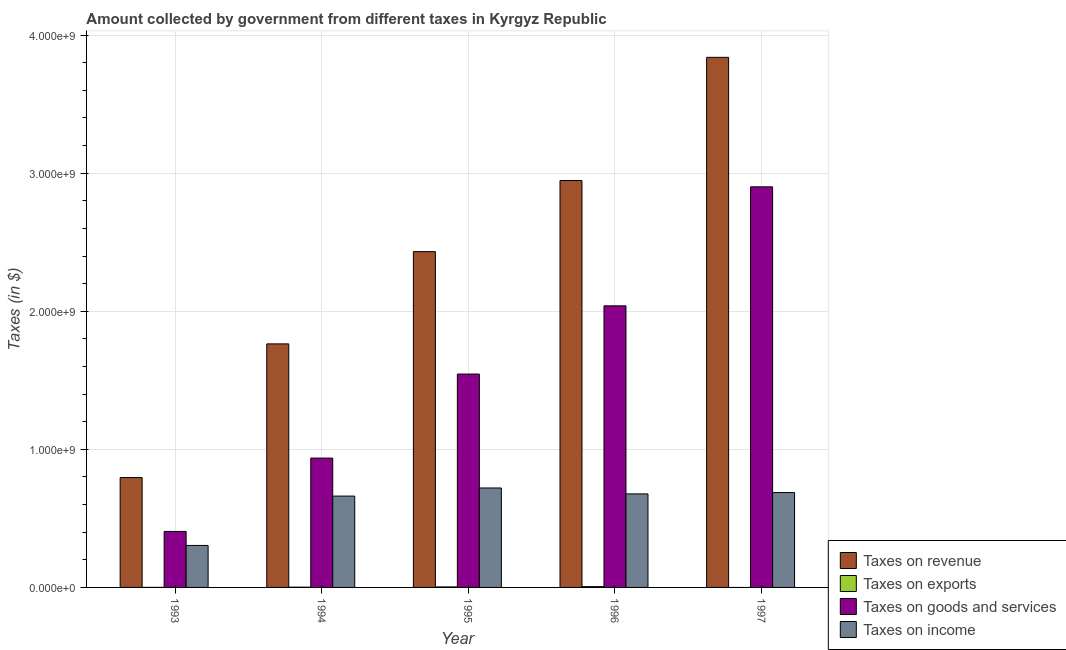Are the number of bars per tick equal to the number of legend labels?
Offer a terse response. No. How many bars are there on the 3rd tick from the right?
Offer a very short reply. 4. In how many cases, is the number of bars for a given year not equal to the number of legend labels?
Give a very brief answer. 1. What is the amount collected as tax on exports in 1995?
Provide a short and direct response. 3.56e+06. Across all years, what is the maximum amount collected as tax on goods?
Your answer should be compact. 2.90e+09. Across all years, what is the minimum amount collected as tax on income?
Give a very brief answer. 3.04e+08. What is the total amount collected as tax on exports in the graph?
Ensure brevity in your answer.  1.14e+07. What is the difference between the amount collected as tax on goods in 1993 and that in 1995?
Ensure brevity in your answer.  -1.14e+09. What is the difference between the amount collected as tax on income in 1997 and the amount collected as tax on exports in 1996?
Keep it short and to the point. 9.58e+06. What is the average amount collected as tax on exports per year?
Your answer should be compact. 2.29e+06. In how many years, is the amount collected as tax on goods greater than 1600000000 $?
Offer a terse response. 2. What is the ratio of the amount collected as tax on revenue in 1996 to that in 1997?
Offer a very short reply. 0.77. What is the difference between the highest and the second highest amount collected as tax on goods?
Offer a very short reply. 8.62e+08. What is the difference between the highest and the lowest amount collected as tax on income?
Offer a terse response. 4.16e+08. In how many years, is the amount collected as tax on revenue greater than the average amount collected as tax on revenue taken over all years?
Keep it short and to the point. 3. Is the sum of the amount collected as tax on revenue in 1994 and 1996 greater than the maximum amount collected as tax on goods across all years?
Offer a terse response. Yes. Is it the case that in every year, the sum of the amount collected as tax on goods and amount collected as tax on exports is greater than the sum of amount collected as tax on income and amount collected as tax on revenue?
Make the answer very short. No. Are all the bars in the graph horizontal?
Make the answer very short. No. What is the difference between two consecutive major ticks on the Y-axis?
Your response must be concise. 1.00e+09. Does the graph contain grids?
Offer a terse response. Yes. Where does the legend appear in the graph?
Your answer should be very brief. Bottom right. How are the legend labels stacked?
Your answer should be very brief. Vertical. What is the title of the graph?
Keep it short and to the point. Amount collected by government from different taxes in Kyrgyz Republic. What is the label or title of the Y-axis?
Make the answer very short. Taxes (in $). What is the Taxes (in $) in Taxes on revenue in 1993?
Your response must be concise. 7.96e+08. What is the Taxes (in $) of Taxes on exports in 1993?
Your answer should be very brief. 1.46e+05. What is the Taxes (in $) in Taxes on goods and services in 1993?
Keep it short and to the point. 4.06e+08. What is the Taxes (in $) in Taxes on income in 1993?
Your response must be concise. 3.04e+08. What is the Taxes (in $) of Taxes on revenue in 1994?
Offer a terse response. 1.76e+09. What is the Taxes (in $) of Taxes on exports in 1994?
Give a very brief answer. 1.81e+06. What is the Taxes (in $) of Taxes on goods and services in 1994?
Provide a succinct answer. 9.37e+08. What is the Taxes (in $) in Taxes on income in 1994?
Make the answer very short. 6.62e+08. What is the Taxes (in $) of Taxes on revenue in 1995?
Keep it short and to the point. 2.43e+09. What is the Taxes (in $) of Taxes on exports in 1995?
Give a very brief answer. 3.56e+06. What is the Taxes (in $) in Taxes on goods and services in 1995?
Your answer should be compact. 1.55e+09. What is the Taxes (in $) in Taxes on income in 1995?
Offer a terse response. 7.20e+08. What is the Taxes (in $) of Taxes on revenue in 1996?
Keep it short and to the point. 2.95e+09. What is the Taxes (in $) of Taxes on exports in 1996?
Offer a very short reply. 5.91e+06. What is the Taxes (in $) in Taxes on goods and services in 1996?
Provide a short and direct response. 2.04e+09. What is the Taxes (in $) of Taxes on income in 1996?
Make the answer very short. 6.77e+08. What is the Taxes (in $) of Taxes on revenue in 1997?
Your answer should be very brief. 3.84e+09. What is the Taxes (in $) of Taxes on goods and services in 1997?
Ensure brevity in your answer.  2.90e+09. What is the Taxes (in $) of Taxes on income in 1997?
Offer a terse response. 6.87e+08. Across all years, what is the maximum Taxes (in $) of Taxes on revenue?
Provide a short and direct response. 3.84e+09. Across all years, what is the maximum Taxes (in $) of Taxes on exports?
Offer a terse response. 5.91e+06. Across all years, what is the maximum Taxes (in $) of Taxes on goods and services?
Make the answer very short. 2.90e+09. Across all years, what is the maximum Taxes (in $) in Taxes on income?
Ensure brevity in your answer.  7.20e+08. Across all years, what is the minimum Taxes (in $) of Taxes on revenue?
Provide a succinct answer. 7.96e+08. Across all years, what is the minimum Taxes (in $) of Taxes on exports?
Offer a terse response. 0. Across all years, what is the minimum Taxes (in $) of Taxes on goods and services?
Keep it short and to the point. 4.06e+08. Across all years, what is the minimum Taxes (in $) of Taxes on income?
Your answer should be very brief. 3.04e+08. What is the total Taxes (in $) in Taxes on revenue in the graph?
Ensure brevity in your answer.  1.18e+1. What is the total Taxes (in $) in Taxes on exports in the graph?
Ensure brevity in your answer.  1.14e+07. What is the total Taxes (in $) of Taxes on goods and services in the graph?
Your answer should be compact. 7.83e+09. What is the total Taxes (in $) of Taxes on income in the graph?
Keep it short and to the point. 3.05e+09. What is the difference between the Taxes (in $) in Taxes on revenue in 1993 and that in 1994?
Offer a very short reply. -9.68e+08. What is the difference between the Taxes (in $) in Taxes on exports in 1993 and that in 1994?
Ensure brevity in your answer.  -1.66e+06. What is the difference between the Taxes (in $) in Taxes on goods and services in 1993 and that in 1994?
Provide a short and direct response. -5.31e+08. What is the difference between the Taxes (in $) in Taxes on income in 1993 and that in 1994?
Your response must be concise. -3.58e+08. What is the difference between the Taxes (in $) in Taxes on revenue in 1993 and that in 1995?
Provide a short and direct response. -1.64e+09. What is the difference between the Taxes (in $) of Taxes on exports in 1993 and that in 1995?
Make the answer very short. -3.42e+06. What is the difference between the Taxes (in $) of Taxes on goods and services in 1993 and that in 1995?
Offer a terse response. -1.14e+09. What is the difference between the Taxes (in $) in Taxes on income in 1993 and that in 1995?
Provide a succinct answer. -4.16e+08. What is the difference between the Taxes (in $) in Taxes on revenue in 1993 and that in 1996?
Provide a short and direct response. -2.15e+09. What is the difference between the Taxes (in $) of Taxes on exports in 1993 and that in 1996?
Your answer should be compact. -5.77e+06. What is the difference between the Taxes (in $) in Taxes on goods and services in 1993 and that in 1996?
Keep it short and to the point. -1.63e+09. What is the difference between the Taxes (in $) of Taxes on income in 1993 and that in 1996?
Provide a short and direct response. -3.73e+08. What is the difference between the Taxes (in $) in Taxes on revenue in 1993 and that in 1997?
Ensure brevity in your answer.  -3.04e+09. What is the difference between the Taxes (in $) in Taxes on goods and services in 1993 and that in 1997?
Give a very brief answer. -2.50e+09. What is the difference between the Taxes (in $) in Taxes on income in 1993 and that in 1997?
Make the answer very short. -3.83e+08. What is the difference between the Taxes (in $) in Taxes on revenue in 1994 and that in 1995?
Offer a very short reply. -6.68e+08. What is the difference between the Taxes (in $) in Taxes on exports in 1994 and that in 1995?
Offer a terse response. -1.76e+06. What is the difference between the Taxes (in $) of Taxes on goods and services in 1994 and that in 1995?
Your answer should be very brief. -6.09e+08. What is the difference between the Taxes (in $) of Taxes on income in 1994 and that in 1995?
Give a very brief answer. -5.88e+07. What is the difference between the Taxes (in $) in Taxes on revenue in 1994 and that in 1996?
Give a very brief answer. -1.18e+09. What is the difference between the Taxes (in $) in Taxes on exports in 1994 and that in 1996?
Ensure brevity in your answer.  -4.11e+06. What is the difference between the Taxes (in $) of Taxes on goods and services in 1994 and that in 1996?
Offer a very short reply. -1.10e+09. What is the difference between the Taxes (in $) in Taxes on income in 1994 and that in 1996?
Offer a very short reply. -1.59e+07. What is the difference between the Taxes (in $) in Taxes on revenue in 1994 and that in 1997?
Make the answer very short. -2.08e+09. What is the difference between the Taxes (in $) in Taxes on goods and services in 1994 and that in 1997?
Keep it short and to the point. -1.96e+09. What is the difference between the Taxes (in $) in Taxes on income in 1994 and that in 1997?
Make the answer very short. -2.55e+07. What is the difference between the Taxes (in $) in Taxes on revenue in 1995 and that in 1996?
Your answer should be compact. -5.15e+08. What is the difference between the Taxes (in $) of Taxes on exports in 1995 and that in 1996?
Keep it short and to the point. -2.35e+06. What is the difference between the Taxes (in $) of Taxes on goods and services in 1995 and that in 1996?
Give a very brief answer. -4.94e+08. What is the difference between the Taxes (in $) of Taxes on income in 1995 and that in 1996?
Keep it short and to the point. 4.29e+07. What is the difference between the Taxes (in $) of Taxes on revenue in 1995 and that in 1997?
Give a very brief answer. -1.41e+09. What is the difference between the Taxes (in $) of Taxes on goods and services in 1995 and that in 1997?
Your answer should be compact. -1.36e+09. What is the difference between the Taxes (in $) of Taxes on income in 1995 and that in 1997?
Ensure brevity in your answer.  3.33e+07. What is the difference between the Taxes (in $) in Taxes on revenue in 1996 and that in 1997?
Offer a terse response. -8.92e+08. What is the difference between the Taxes (in $) of Taxes on goods and services in 1996 and that in 1997?
Offer a very short reply. -8.62e+08. What is the difference between the Taxes (in $) of Taxes on income in 1996 and that in 1997?
Give a very brief answer. -9.58e+06. What is the difference between the Taxes (in $) of Taxes on revenue in 1993 and the Taxes (in $) of Taxes on exports in 1994?
Keep it short and to the point. 7.94e+08. What is the difference between the Taxes (in $) of Taxes on revenue in 1993 and the Taxes (in $) of Taxes on goods and services in 1994?
Offer a very short reply. -1.41e+08. What is the difference between the Taxes (in $) of Taxes on revenue in 1993 and the Taxes (in $) of Taxes on income in 1994?
Give a very brief answer. 1.34e+08. What is the difference between the Taxes (in $) of Taxes on exports in 1993 and the Taxes (in $) of Taxes on goods and services in 1994?
Your answer should be very brief. -9.37e+08. What is the difference between the Taxes (in $) in Taxes on exports in 1993 and the Taxes (in $) in Taxes on income in 1994?
Provide a succinct answer. -6.61e+08. What is the difference between the Taxes (in $) of Taxes on goods and services in 1993 and the Taxes (in $) of Taxes on income in 1994?
Your answer should be very brief. -2.56e+08. What is the difference between the Taxes (in $) of Taxes on revenue in 1993 and the Taxes (in $) of Taxes on exports in 1995?
Provide a short and direct response. 7.92e+08. What is the difference between the Taxes (in $) in Taxes on revenue in 1993 and the Taxes (in $) in Taxes on goods and services in 1995?
Offer a terse response. -7.50e+08. What is the difference between the Taxes (in $) in Taxes on revenue in 1993 and the Taxes (in $) in Taxes on income in 1995?
Offer a terse response. 7.54e+07. What is the difference between the Taxes (in $) in Taxes on exports in 1993 and the Taxes (in $) in Taxes on goods and services in 1995?
Offer a very short reply. -1.55e+09. What is the difference between the Taxes (in $) in Taxes on exports in 1993 and the Taxes (in $) in Taxes on income in 1995?
Keep it short and to the point. -7.20e+08. What is the difference between the Taxes (in $) of Taxes on goods and services in 1993 and the Taxes (in $) of Taxes on income in 1995?
Ensure brevity in your answer.  -3.15e+08. What is the difference between the Taxes (in $) of Taxes on revenue in 1993 and the Taxes (in $) of Taxes on exports in 1996?
Keep it short and to the point. 7.90e+08. What is the difference between the Taxes (in $) in Taxes on revenue in 1993 and the Taxes (in $) in Taxes on goods and services in 1996?
Offer a terse response. -1.24e+09. What is the difference between the Taxes (in $) in Taxes on revenue in 1993 and the Taxes (in $) in Taxes on income in 1996?
Your answer should be compact. 1.18e+08. What is the difference between the Taxes (in $) in Taxes on exports in 1993 and the Taxes (in $) in Taxes on goods and services in 1996?
Provide a succinct answer. -2.04e+09. What is the difference between the Taxes (in $) of Taxes on exports in 1993 and the Taxes (in $) of Taxes on income in 1996?
Your answer should be compact. -6.77e+08. What is the difference between the Taxes (in $) of Taxes on goods and services in 1993 and the Taxes (in $) of Taxes on income in 1996?
Ensure brevity in your answer.  -2.72e+08. What is the difference between the Taxes (in $) in Taxes on revenue in 1993 and the Taxes (in $) in Taxes on goods and services in 1997?
Your response must be concise. -2.11e+09. What is the difference between the Taxes (in $) of Taxes on revenue in 1993 and the Taxes (in $) of Taxes on income in 1997?
Offer a terse response. 1.09e+08. What is the difference between the Taxes (in $) in Taxes on exports in 1993 and the Taxes (in $) in Taxes on goods and services in 1997?
Your answer should be very brief. -2.90e+09. What is the difference between the Taxes (in $) of Taxes on exports in 1993 and the Taxes (in $) of Taxes on income in 1997?
Your response must be concise. -6.87e+08. What is the difference between the Taxes (in $) in Taxes on goods and services in 1993 and the Taxes (in $) in Taxes on income in 1997?
Give a very brief answer. -2.81e+08. What is the difference between the Taxes (in $) of Taxes on revenue in 1994 and the Taxes (in $) of Taxes on exports in 1995?
Your answer should be compact. 1.76e+09. What is the difference between the Taxes (in $) in Taxes on revenue in 1994 and the Taxes (in $) in Taxes on goods and services in 1995?
Your answer should be very brief. 2.19e+08. What is the difference between the Taxes (in $) of Taxes on revenue in 1994 and the Taxes (in $) of Taxes on income in 1995?
Give a very brief answer. 1.04e+09. What is the difference between the Taxes (in $) of Taxes on exports in 1994 and the Taxes (in $) of Taxes on goods and services in 1995?
Offer a terse response. -1.54e+09. What is the difference between the Taxes (in $) in Taxes on exports in 1994 and the Taxes (in $) in Taxes on income in 1995?
Make the answer very short. -7.18e+08. What is the difference between the Taxes (in $) in Taxes on goods and services in 1994 and the Taxes (in $) in Taxes on income in 1995?
Give a very brief answer. 2.16e+08. What is the difference between the Taxes (in $) in Taxes on revenue in 1994 and the Taxes (in $) in Taxes on exports in 1996?
Offer a terse response. 1.76e+09. What is the difference between the Taxes (in $) in Taxes on revenue in 1994 and the Taxes (in $) in Taxes on goods and services in 1996?
Your answer should be very brief. -2.76e+08. What is the difference between the Taxes (in $) of Taxes on revenue in 1994 and the Taxes (in $) of Taxes on income in 1996?
Offer a very short reply. 1.09e+09. What is the difference between the Taxes (in $) in Taxes on exports in 1994 and the Taxes (in $) in Taxes on goods and services in 1996?
Offer a very short reply. -2.04e+09. What is the difference between the Taxes (in $) in Taxes on exports in 1994 and the Taxes (in $) in Taxes on income in 1996?
Keep it short and to the point. -6.76e+08. What is the difference between the Taxes (in $) of Taxes on goods and services in 1994 and the Taxes (in $) of Taxes on income in 1996?
Offer a terse response. 2.59e+08. What is the difference between the Taxes (in $) in Taxes on revenue in 1994 and the Taxes (in $) in Taxes on goods and services in 1997?
Your answer should be compact. -1.14e+09. What is the difference between the Taxes (in $) of Taxes on revenue in 1994 and the Taxes (in $) of Taxes on income in 1997?
Your answer should be compact. 1.08e+09. What is the difference between the Taxes (in $) in Taxes on exports in 1994 and the Taxes (in $) in Taxes on goods and services in 1997?
Keep it short and to the point. -2.90e+09. What is the difference between the Taxes (in $) of Taxes on exports in 1994 and the Taxes (in $) of Taxes on income in 1997?
Offer a very short reply. -6.85e+08. What is the difference between the Taxes (in $) of Taxes on goods and services in 1994 and the Taxes (in $) of Taxes on income in 1997?
Offer a terse response. 2.50e+08. What is the difference between the Taxes (in $) of Taxes on revenue in 1995 and the Taxes (in $) of Taxes on exports in 1996?
Offer a very short reply. 2.43e+09. What is the difference between the Taxes (in $) of Taxes on revenue in 1995 and the Taxes (in $) of Taxes on goods and services in 1996?
Your response must be concise. 3.93e+08. What is the difference between the Taxes (in $) in Taxes on revenue in 1995 and the Taxes (in $) in Taxes on income in 1996?
Your response must be concise. 1.75e+09. What is the difference between the Taxes (in $) of Taxes on exports in 1995 and the Taxes (in $) of Taxes on goods and services in 1996?
Make the answer very short. -2.04e+09. What is the difference between the Taxes (in $) in Taxes on exports in 1995 and the Taxes (in $) in Taxes on income in 1996?
Your answer should be very brief. -6.74e+08. What is the difference between the Taxes (in $) in Taxes on goods and services in 1995 and the Taxes (in $) in Taxes on income in 1996?
Provide a succinct answer. 8.68e+08. What is the difference between the Taxes (in $) in Taxes on revenue in 1995 and the Taxes (in $) in Taxes on goods and services in 1997?
Keep it short and to the point. -4.69e+08. What is the difference between the Taxes (in $) in Taxes on revenue in 1995 and the Taxes (in $) in Taxes on income in 1997?
Make the answer very short. 1.75e+09. What is the difference between the Taxes (in $) of Taxes on exports in 1995 and the Taxes (in $) of Taxes on goods and services in 1997?
Make the answer very short. -2.90e+09. What is the difference between the Taxes (in $) of Taxes on exports in 1995 and the Taxes (in $) of Taxes on income in 1997?
Your response must be concise. -6.83e+08. What is the difference between the Taxes (in $) of Taxes on goods and services in 1995 and the Taxes (in $) of Taxes on income in 1997?
Offer a terse response. 8.58e+08. What is the difference between the Taxes (in $) of Taxes on revenue in 1996 and the Taxes (in $) of Taxes on goods and services in 1997?
Offer a terse response. 4.57e+07. What is the difference between the Taxes (in $) of Taxes on revenue in 1996 and the Taxes (in $) of Taxes on income in 1997?
Make the answer very short. 2.26e+09. What is the difference between the Taxes (in $) in Taxes on exports in 1996 and the Taxes (in $) in Taxes on goods and services in 1997?
Make the answer very short. -2.90e+09. What is the difference between the Taxes (in $) of Taxes on exports in 1996 and the Taxes (in $) of Taxes on income in 1997?
Keep it short and to the point. -6.81e+08. What is the difference between the Taxes (in $) of Taxes on goods and services in 1996 and the Taxes (in $) of Taxes on income in 1997?
Ensure brevity in your answer.  1.35e+09. What is the average Taxes (in $) of Taxes on revenue per year?
Your answer should be compact. 2.36e+09. What is the average Taxes (in $) of Taxes on exports per year?
Your response must be concise. 2.29e+06. What is the average Taxes (in $) in Taxes on goods and services per year?
Your response must be concise. 1.57e+09. What is the average Taxes (in $) in Taxes on income per year?
Provide a short and direct response. 6.10e+08. In the year 1993, what is the difference between the Taxes (in $) of Taxes on revenue and Taxes (in $) of Taxes on exports?
Make the answer very short. 7.96e+08. In the year 1993, what is the difference between the Taxes (in $) in Taxes on revenue and Taxes (in $) in Taxes on goods and services?
Keep it short and to the point. 3.90e+08. In the year 1993, what is the difference between the Taxes (in $) of Taxes on revenue and Taxes (in $) of Taxes on income?
Make the answer very short. 4.92e+08. In the year 1993, what is the difference between the Taxes (in $) in Taxes on exports and Taxes (in $) in Taxes on goods and services?
Keep it short and to the point. -4.05e+08. In the year 1993, what is the difference between the Taxes (in $) in Taxes on exports and Taxes (in $) in Taxes on income?
Your response must be concise. -3.04e+08. In the year 1993, what is the difference between the Taxes (in $) of Taxes on goods and services and Taxes (in $) of Taxes on income?
Provide a succinct answer. 1.02e+08. In the year 1994, what is the difference between the Taxes (in $) in Taxes on revenue and Taxes (in $) in Taxes on exports?
Provide a short and direct response. 1.76e+09. In the year 1994, what is the difference between the Taxes (in $) of Taxes on revenue and Taxes (in $) of Taxes on goods and services?
Provide a short and direct response. 8.27e+08. In the year 1994, what is the difference between the Taxes (in $) in Taxes on revenue and Taxes (in $) in Taxes on income?
Your answer should be compact. 1.10e+09. In the year 1994, what is the difference between the Taxes (in $) of Taxes on exports and Taxes (in $) of Taxes on goods and services?
Offer a terse response. -9.35e+08. In the year 1994, what is the difference between the Taxes (in $) of Taxes on exports and Taxes (in $) of Taxes on income?
Ensure brevity in your answer.  -6.60e+08. In the year 1994, what is the difference between the Taxes (in $) of Taxes on goods and services and Taxes (in $) of Taxes on income?
Your response must be concise. 2.75e+08. In the year 1995, what is the difference between the Taxes (in $) in Taxes on revenue and Taxes (in $) in Taxes on exports?
Provide a short and direct response. 2.43e+09. In the year 1995, what is the difference between the Taxes (in $) in Taxes on revenue and Taxes (in $) in Taxes on goods and services?
Provide a short and direct response. 8.87e+08. In the year 1995, what is the difference between the Taxes (in $) of Taxes on revenue and Taxes (in $) of Taxes on income?
Give a very brief answer. 1.71e+09. In the year 1995, what is the difference between the Taxes (in $) in Taxes on exports and Taxes (in $) in Taxes on goods and services?
Offer a very short reply. -1.54e+09. In the year 1995, what is the difference between the Taxes (in $) in Taxes on exports and Taxes (in $) in Taxes on income?
Your answer should be very brief. -7.17e+08. In the year 1995, what is the difference between the Taxes (in $) of Taxes on goods and services and Taxes (in $) of Taxes on income?
Keep it short and to the point. 8.25e+08. In the year 1996, what is the difference between the Taxes (in $) in Taxes on revenue and Taxes (in $) in Taxes on exports?
Give a very brief answer. 2.94e+09. In the year 1996, what is the difference between the Taxes (in $) in Taxes on revenue and Taxes (in $) in Taxes on goods and services?
Your answer should be compact. 9.08e+08. In the year 1996, what is the difference between the Taxes (in $) of Taxes on revenue and Taxes (in $) of Taxes on income?
Offer a terse response. 2.27e+09. In the year 1996, what is the difference between the Taxes (in $) of Taxes on exports and Taxes (in $) of Taxes on goods and services?
Your response must be concise. -2.03e+09. In the year 1996, what is the difference between the Taxes (in $) of Taxes on exports and Taxes (in $) of Taxes on income?
Offer a terse response. -6.71e+08. In the year 1996, what is the difference between the Taxes (in $) in Taxes on goods and services and Taxes (in $) in Taxes on income?
Keep it short and to the point. 1.36e+09. In the year 1997, what is the difference between the Taxes (in $) of Taxes on revenue and Taxes (in $) of Taxes on goods and services?
Your answer should be compact. 9.38e+08. In the year 1997, what is the difference between the Taxes (in $) of Taxes on revenue and Taxes (in $) of Taxes on income?
Offer a very short reply. 3.15e+09. In the year 1997, what is the difference between the Taxes (in $) of Taxes on goods and services and Taxes (in $) of Taxes on income?
Your answer should be very brief. 2.21e+09. What is the ratio of the Taxes (in $) in Taxes on revenue in 1993 to that in 1994?
Offer a terse response. 0.45. What is the ratio of the Taxes (in $) of Taxes on exports in 1993 to that in 1994?
Your answer should be compact. 0.08. What is the ratio of the Taxes (in $) of Taxes on goods and services in 1993 to that in 1994?
Ensure brevity in your answer.  0.43. What is the ratio of the Taxes (in $) of Taxes on income in 1993 to that in 1994?
Your answer should be very brief. 0.46. What is the ratio of the Taxes (in $) in Taxes on revenue in 1993 to that in 1995?
Give a very brief answer. 0.33. What is the ratio of the Taxes (in $) of Taxes on exports in 1993 to that in 1995?
Make the answer very short. 0.04. What is the ratio of the Taxes (in $) of Taxes on goods and services in 1993 to that in 1995?
Your answer should be compact. 0.26. What is the ratio of the Taxes (in $) in Taxes on income in 1993 to that in 1995?
Provide a succinct answer. 0.42. What is the ratio of the Taxes (in $) in Taxes on revenue in 1993 to that in 1996?
Ensure brevity in your answer.  0.27. What is the ratio of the Taxes (in $) in Taxes on exports in 1993 to that in 1996?
Make the answer very short. 0.02. What is the ratio of the Taxes (in $) in Taxes on goods and services in 1993 to that in 1996?
Your response must be concise. 0.2. What is the ratio of the Taxes (in $) of Taxes on income in 1993 to that in 1996?
Offer a very short reply. 0.45. What is the ratio of the Taxes (in $) in Taxes on revenue in 1993 to that in 1997?
Offer a terse response. 0.21. What is the ratio of the Taxes (in $) in Taxes on goods and services in 1993 to that in 1997?
Give a very brief answer. 0.14. What is the ratio of the Taxes (in $) of Taxes on income in 1993 to that in 1997?
Your response must be concise. 0.44. What is the ratio of the Taxes (in $) of Taxes on revenue in 1994 to that in 1995?
Offer a very short reply. 0.73. What is the ratio of the Taxes (in $) in Taxes on exports in 1994 to that in 1995?
Your response must be concise. 0.51. What is the ratio of the Taxes (in $) of Taxes on goods and services in 1994 to that in 1995?
Make the answer very short. 0.61. What is the ratio of the Taxes (in $) of Taxes on income in 1994 to that in 1995?
Your response must be concise. 0.92. What is the ratio of the Taxes (in $) of Taxes on revenue in 1994 to that in 1996?
Your answer should be very brief. 0.6. What is the ratio of the Taxes (in $) of Taxes on exports in 1994 to that in 1996?
Offer a terse response. 0.31. What is the ratio of the Taxes (in $) in Taxes on goods and services in 1994 to that in 1996?
Provide a short and direct response. 0.46. What is the ratio of the Taxes (in $) of Taxes on income in 1994 to that in 1996?
Offer a terse response. 0.98. What is the ratio of the Taxes (in $) in Taxes on revenue in 1994 to that in 1997?
Your response must be concise. 0.46. What is the ratio of the Taxes (in $) in Taxes on goods and services in 1994 to that in 1997?
Your answer should be compact. 0.32. What is the ratio of the Taxes (in $) in Taxes on income in 1994 to that in 1997?
Give a very brief answer. 0.96. What is the ratio of the Taxes (in $) of Taxes on revenue in 1995 to that in 1996?
Your answer should be compact. 0.83. What is the ratio of the Taxes (in $) in Taxes on exports in 1995 to that in 1996?
Provide a short and direct response. 0.6. What is the ratio of the Taxes (in $) in Taxes on goods and services in 1995 to that in 1996?
Offer a very short reply. 0.76. What is the ratio of the Taxes (in $) of Taxes on income in 1995 to that in 1996?
Provide a short and direct response. 1.06. What is the ratio of the Taxes (in $) of Taxes on revenue in 1995 to that in 1997?
Offer a terse response. 0.63. What is the ratio of the Taxes (in $) in Taxes on goods and services in 1995 to that in 1997?
Provide a short and direct response. 0.53. What is the ratio of the Taxes (in $) in Taxes on income in 1995 to that in 1997?
Provide a succinct answer. 1.05. What is the ratio of the Taxes (in $) in Taxes on revenue in 1996 to that in 1997?
Make the answer very short. 0.77. What is the ratio of the Taxes (in $) of Taxes on goods and services in 1996 to that in 1997?
Offer a terse response. 0.7. What is the ratio of the Taxes (in $) in Taxes on income in 1996 to that in 1997?
Ensure brevity in your answer.  0.99. What is the difference between the highest and the second highest Taxes (in $) of Taxes on revenue?
Provide a short and direct response. 8.92e+08. What is the difference between the highest and the second highest Taxes (in $) of Taxes on exports?
Make the answer very short. 2.35e+06. What is the difference between the highest and the second highest Taxes (in $) of Taxes on goods and services?
Your answer should be compact. 8.62e+08. What is the difference between the highest and the second highest Taxes (in $) of Taxes on income?
Offer a very short reply. 3.33e+07. What is the difference between the highest and the lowest Taxes (in $) in Taxes on revenue?
Give a very brief answer. 3.04e+09. What is the difference between the highest and the lowest Taxes (in $) of Taxes on exports?
Offer a terse response. 5.91e+06. What is the difference between the highest and the lowest Taxes (in $) of Taxes on goods and services?
Keep it short and to the point. 2.50e+09. What is the difference between the highest and the lowest Taxes (in $) in Taxes on income?
Ensure brevity in your answer.  4.16e+08. 